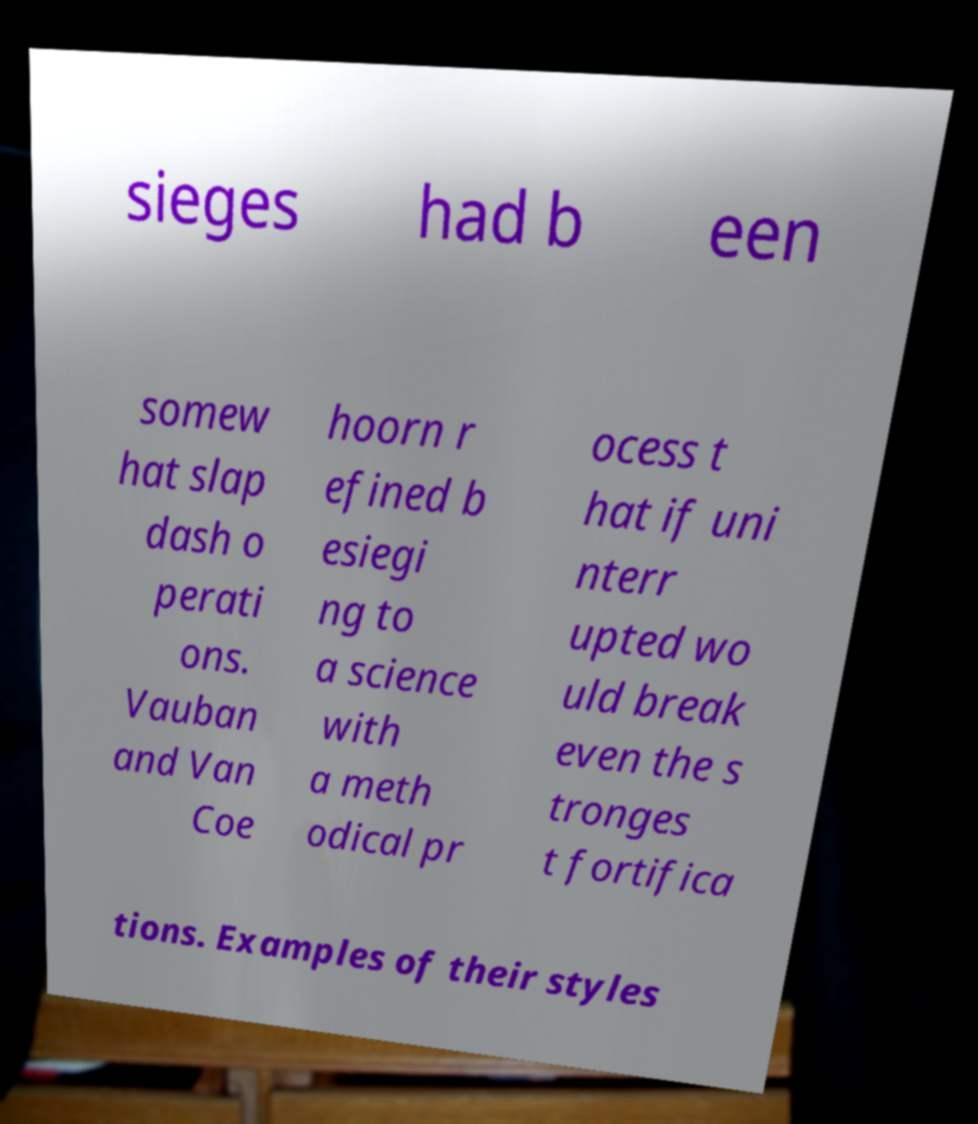There's text embedded in this image that I need extracted. Can you transcribe it verbatim? sieges had b een somew hat slap dash o perati ons. Vauban and Van Coe hoorn r efined b esiegi ng to a science with a meth odical pr ocess t hat if uni nterr upted wo uld break even the s tronges t fortifica tions. Examples of their styles 